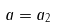<formula> <loc_0><loc_0><loc_500><loc_500>a = a _ { 2 }</formula> 